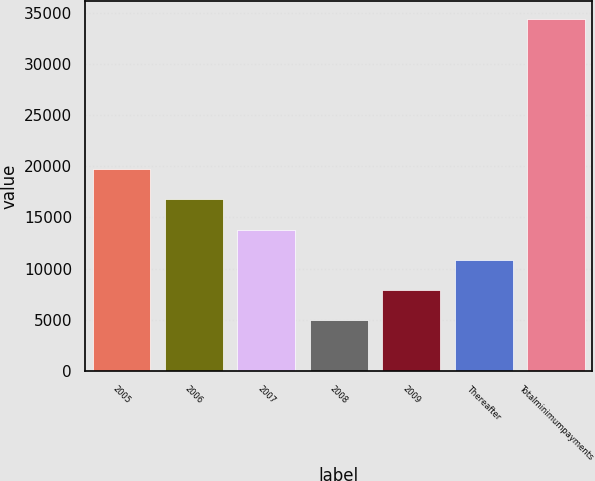<chart> <loc_0><loc_0><loc_500><loc_500><bar_chart><fcel>2005<fcel>2006<fcel>2007<fcel>2008<fcel>2009<fcel>Thereafter<fcel>Totalminimumpayments<nl><fcel>19694.5<fcel>16748.4<fcel>13802.3<fcel>4964<fcel>7910.1<fcel>10856.2<fcel>34425<nl></chart> 